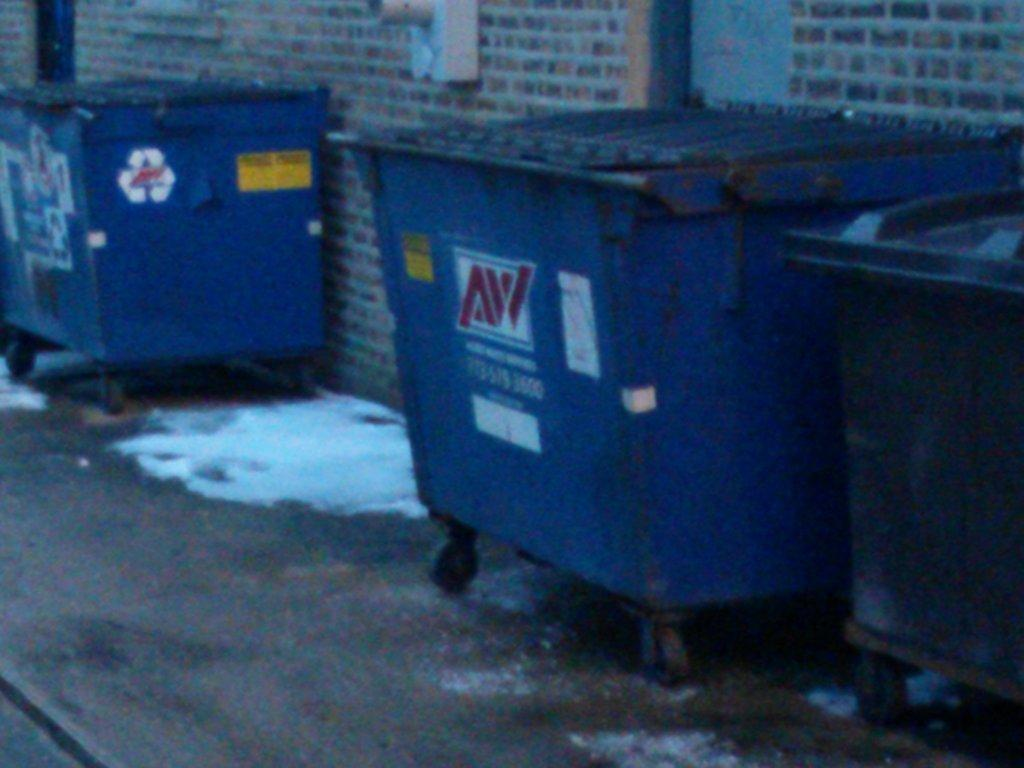<image>
Describe the image concisely. Blue garbage can in an alley that says AW on it. 